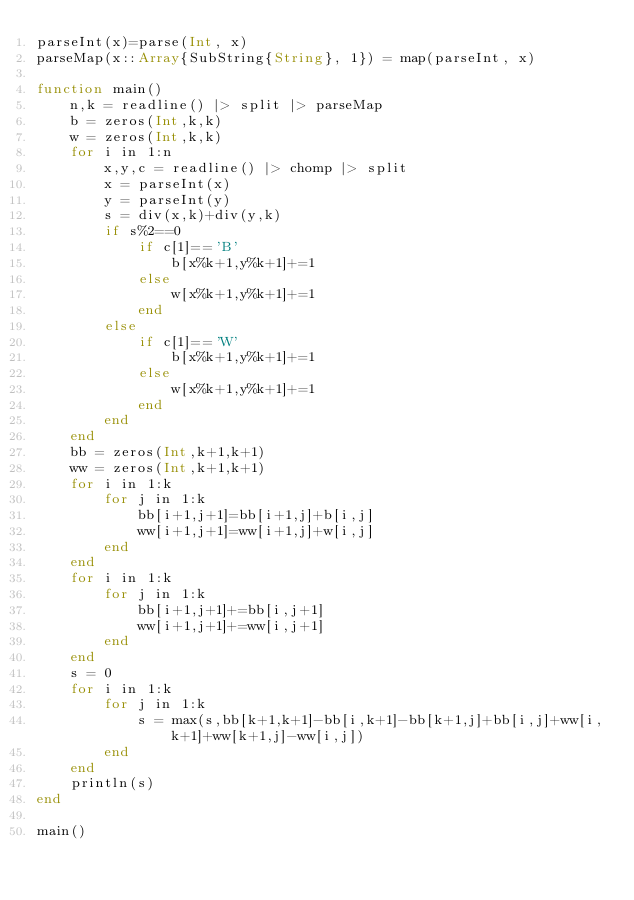Convert code to text. <code><loc_0><loc_0><loc_500><loc_500><_Julia_>parseInt(x)=parse(Int, x)
parseMap(x::Array{SubString{String}, 1}) = map(parseInt, x)

function main()
	n,k = readline() |> split |> parseMap
	b = zeros(Int,k,k)
	w = zeros(Int,k,k)
	for i in 1:n
		x,y,c = readline() |> chomp |> split
		x = parseInt(x)
		y = parseInt(y)
		s = div(x,k)+div(y,k)
		if s%2==0
			if c[1]=='B'
				b[x%k+1,y%k+1]+=1
			else
				w[x%k+1,y%k+1]+=1
			end
		else
			if c[1]=='W'
				b[x%k+1,y%k+1]+=1
			else
				w[x%k+1,y%k+1]+=1
			end
		end
	end
	bb = zeros(Int,k+1,k+1)
	ww = zeros(Int,k+1,k+1)
	for i in 1:k
		for j in 1:k
			bb[i+1,j+1]=bb[i+1,j]+b[i,j]
			ww[i+1,j+1]=ww[i+1,j]+w[i,j]
		end
	end
	for i in 1:k
		for j in 1:k
			bb[i+1,j+1]+=bb[i,j+1]
			ww[i+1,j+1]+=ww[i,j+1]
		end
	end
	s = 0
	for i in 1:k
		for j in 1:k
			s = max(s,bb[k+1,k+1]-bb[i,k+1]-bb[k+1,j]+bb[i,j]+ww[i,k+1]+ww[k+1,j]-ww[i,j])
		end
	end
	println(s)
end

main()</code> 